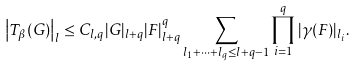Convert formula to latex. <formula><loc_0><loc_0><loc_500><loc_500>\left | T _ { \beta } ( G ) \right | _ { l } \leq C _ { l , q } | G | _ { l + q } | F | ^ { q } _ { l + q } \sum _ { l _ { 1 } + \dots + l _ { q } \leq l + q - 1 } \prod _ { i = 1 } ^ { q } | \gamma ( F ) | _ { l _ { i } } .</formula> 